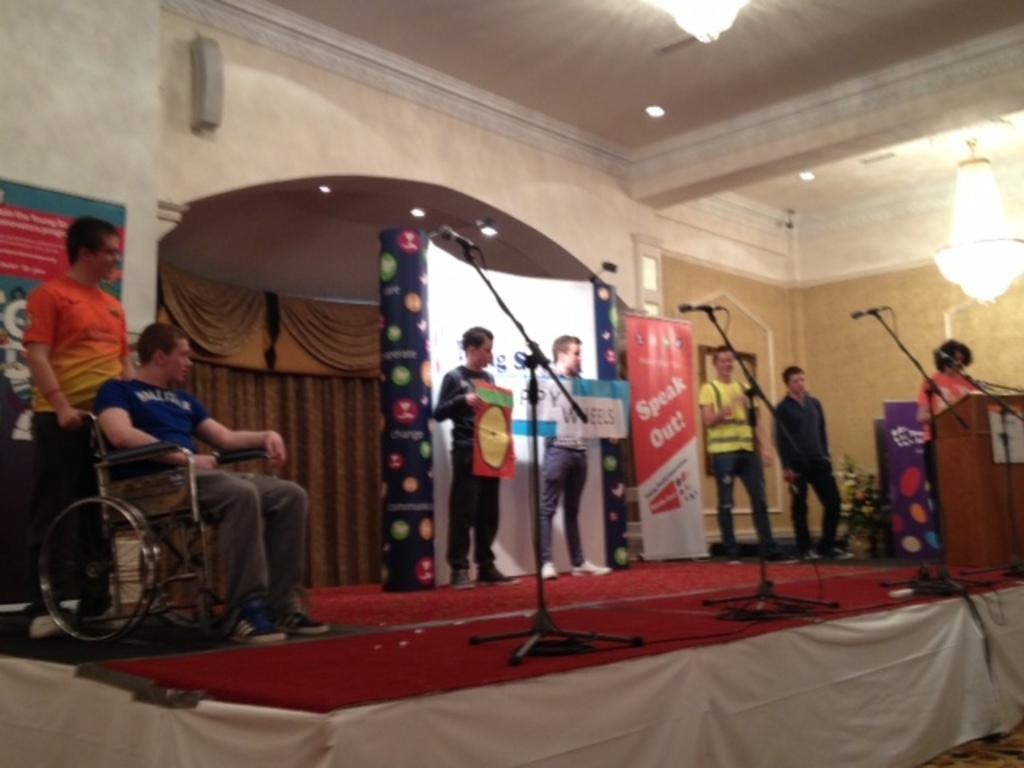What is the main structure in the image? There is a podium in the image. What can be seen near the podium? There are microphones in the image. Who or what is present in the image? There are people in the image. What type of lighting is visible in the image? There are lights in the image. What architectural feature can be seen in the image? There is an arch in the image. What type of fabric is present in the image? There are curtains in the image. What type of floor covering is visible in the image? There is a floor mat in the image. What type of mobility aid is present in the image? There is a wheelchair in the image. What type of signage is present in the image? There are posters with text in the image. How many clocks are hanging on the wall in the image? There are no clocks visible in the image. What type of bridge can be seen connecting the two buildings in the image? There is no bridge present in the image. What type of sponge is being used to clean the floor in the image? There is no sponge visible in the image. 